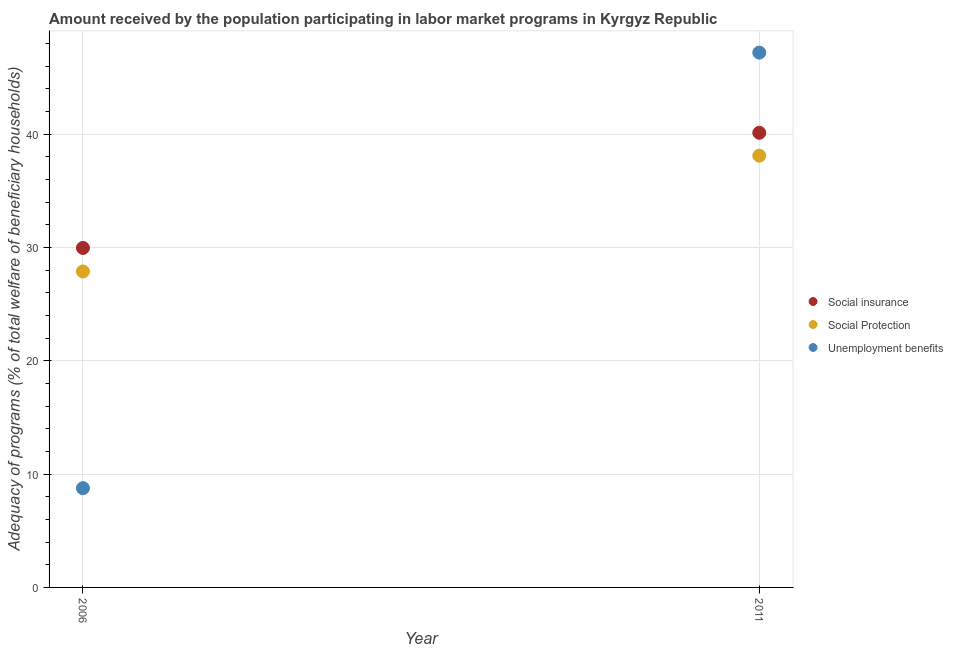How many different coloured dotlines are there?
Your response must be concise. 3. Is the number of dotlines equal to the number of legend labels?
Provide a succinct answer. Yes. What is the amount received by the population participating in social insurance programs in 2006?
Offer a very short reply. 29.96. Across all years, what is the maximum amount received by the population participating in unemployment benefits programs?
Ensure brevity in your answer.  47.19. Across all years, what is the minimum amount received by the population participating in social insurance programs?
Your answer should be very brief. 29.96. In which year was the amount received by the population participating in social protection programs minimum?
Make the answer very short. 2006. What is the total amount received by the population participating in social insurance programs in the graph?
Provide a short and direct response. 70.07. What is the difference between the amount received by the population participating in social insurance programs in 2006 and that in 2011?
Your answer should be compact. -10.16. What is the difference between the amount received by the population participating in unemployment benefits programs in 2011 and the amount received by the population participating in social protection programs in 2006?
Provide a short and direct response. 19.31. What is the average amount received by the population participating in social protection programs per year?
Ensure brevity in your answer.  32.99. In the year 2006, what is the difference between the amount received by the population participating in unemployment benefits programs and amount received by the population participating in social protection programs?
Your response must be concise. -19.12. What is the ratio of the amount received by the population participating in social insurance programs in 2006 to that in 2011?
Your answer should be very brief. 0.75. Is the amount received by the population participating in unemployment benefits programs in 2006 less than that in 2011?
Provide a short and direct response. Yes. In how many years, is the amount received by the population participating in social insurance programs greater than the average amount received by the population participating in social insurance programs taken over all years?
Your answer should be very brief. 1. Does the amount received by the population participating in social protection programs monotonically increase over the years?
Provide a short and direct response. Yes. Is the amount received by the population participating in social insurance programs strictly less than the amount received by the population participating in social protection programs over the years?
Provide a succinct answer. No. How many dotlines are there?
Keep it short and to the point. 3. How many years are there in the graph?
Provide a short and direct response. 2. What is the difference between two consecutive major ticks on the Y-axis?
Offer a very short reply. 10. Are the values on the major ticks of Y-axis written in scientific E-notation?
Provide a succinct answer. No. Does the graph contain any zero values?
Provide a succinct answer. No. Does the graph contain grids?
Provide a short and direct response. Yes. What is the title of the graph?
Your response must be concise. Amount received by the population participating in labor market programs in Kyrgyz Republic. Does "Agriculture" appear as one of the legend labels in the graph?
Your response must be concise. No. What is the label or title of the Y-axis?
Offer a very short reply. Adequacy of programs (% of total welfare of beneficiary households). What is the Adequacy of programs (% of total welfare of beneficiary households) of Social insurance in 2006?
Your answer should be compact. 29.96. What is the Adequacy of programs (% of total welfare of beneficiary households) in Social Protection in 2006?
Your answer should be very brief. 27.88. What is the Adequacy of programs (% of total welfare of beneficiary households) in Unemployment benefits in 2006?
Give a very brief answer. 8.76. What is the Adequacy of programs (% of total welfare of beneficiary households) in Social insurance in 2011?
Your answer should be very brief. 40.12. What is the Adequacy of programs (% of total welfare of beneficiary households) in Social Protection in 2011?
Provide a succinct answer. 38.1. What is the Adequacy of programs (% of total welfare of beneficiary households) in Unemployment benefits in 2011?
Your answer should be compact. 47.19. Across all years, what is the maximum Adequacy of programs (% of total welfare of beneficiary households) of Social insurance?
Keep it short and to the point. 40.12. Across all years, what is the maximum Adequacy of programs (% of total welfare of beneficiary households) of Social Protection?
Keep it short and to the point. 38.1. Across all years, what is the maximum Adequacy of programs (% of total welfare of beneficiary households) in Unemployment benefits?
Make the answer very short. 47.19. Across all years, what is the minimum Adequacy of programs (% of total welfare of beneficiary households) of Social insurance?
Your answer should be very brief. 29.96. Across all years, what is the minimum Adequacy of programs (% of total welfare of beneficiary households) in Social Protection?
Make the answer very short. 27.88. Across all years, what is the minimum Adequacy of programs (% of total welfare of beneficiary households) of Unemployment benefits?
Offer a very short reply. 8.76. What is the total Adequacy of programs (% of total welfare of beneficiary households) of Social insurance in the graph?
Your answer should be very brief. 70.07. What is the total Adequacy of programs (% of total welfare of beneficiary households) of Social Protection in the graph?
Provide a succinct answer. 65.98. What is the total Adequacy of programs (% of total welfare of beneficiary households) of Unemployment benefits in the graph?
Offer a terse response. 55.95. What is the difference between the Adequacy of programs (% of total welfare of beneficiary households) of Social insurance in 2006 and that in 2011?
Give a very brief answer. -10.16. What is the difference between the Adequacy of programs (% of total welfare of beneficiary households) of Social Protection in 2006 and that in 2011?
Your response must be concise. -10.22. What is the difference between the Adequacy of programs (% of total welfare of beneficiary households) of Unemployment benefits in 2006 and that in 2011?
Offer a terse response. -38.43. What is the difference between the Adequacy of programs (% of total welfare of beneficiary households) of Social insurance in 2006 and the Adequacy of programs (% of total welfare of beneficiary households) of Social Protection in 2011?
Offer a terse response. -8.14. What is the difference between the Adequacy of programs (% of total welfare of beneficiary households) in Social insurance in 2006 and the Adequacy of programs (% of total welfare of beneficiary households) in Unemployment benefits in 2011?
Keep it short and to the point. -17.24. What is the difference between the Adequacy of programs (% of total welfare of beneficiary households) in Social Protection in 2006 and the Adequacy of programs (% of total welfare of beneficiary households) in Unemployment benefits in 2011?
Your response must be concise. -19.31. What is the average Adequacy of programs (% of total welfare of beneficiary households) of Social insurance per year?
Make the answer very short. 35.04. What is the average Adequacy of programs (% of total welfare of beneficiary households) of Social Protection per year?
Your answer should be very brief. 32.99. What is the average Adequacy of programs (% of total welfare of beneficiary households) of Unemployment benefits per year?
Make the answer very short. 27.98. In the year 2006, what is the difference between the Adequacy of programs (% of total welfare of beneficiary households) in Social insurance and Adequacy of programs (% of total welfare of beneficiary households) in Social Protection?
Provide a short and direct response. 2.08. In the year 2006, what is the difference between the Adequacy of programs (% of total welfare of beneficiary households) of Social insurance and Adequacy of programs (% of total welfare of beneficiary households) of Unemployment benefits?
Provide a short and direct response. 21.2. In the year 2006, what is the difference between the Adequacy of programs (% of total welfare of beneficiary households) in Social Protection and Adequacy of programs (% of total welfare of beneficiary households) in Unemployment benefits?
Ensure brevity in your answer.  19.12. In the year 2011, what is the difference between the Adequacy of programs (% of total welfare of beneficiary households) in Social insurance and Adequacy of programs (% of total welfare of beneficiary households) in Social Protection?
Ensure brevity in your answer.  2.02. In the year 2011, what is the difference between the Adequacy of programs (% of total welfare of beneficiary households) of Social insurance and Adequacy of programs (% of total welfare of beneficiary households) of Unemployment benefits?
Offer a very short reply. -7.08. In the year 2011, what is the difference between the Adequacy of programs (% of total welfare of beneficiary households) of Social Protection and Adequacy of programs (% of total welfare of beneficiary households) of Unemployment benefits?
Keep it short and to the point. -9.09. What is the ratio of the Adequacy of programs (% of total welfare of beneficiary households) of Social insurance in 2006 to that in 2011?
Your answer should be compact. 0.75. What is the ratio of the Adequacy of programs (% of total welfare of beneficiary households) of Social Protection in 2006 to that in 2011?
Provide a succinct answer. 0.73. What is the ratio of the Adequacy of programs (% of total welfare of beneficiary households) in Unemployment benefits in 2006 to that in 2011?
Your response must be concise. 0.19. What is the difference between the highest and the second highest Adequacy of programs (% of total welfare of beneficiary households) of Social insurance?
Give a very brief answer. 10.16. What is the difference between the highest and the second highest Adequacy of programs (% of total welfare of beneficiary households) of Social Protection?
Offer a terse response. 10.22. What is the difference between the highest and the second highest Adequacy of programs (% of total welfare of beneficiary households) of Unemployment benefits?
Give a very brief answer. 38.43. What is the difference between the highest and the lowest Adequacy of programs (% of total welfare of beneficiary households) in Social insurance?
Make the answer very short. 10.16. What is the difference between the highest and the lowest Adequacy of programs (% of total welfare of beneficiary households) of Social Protection?
Keep it short and to the point. 10.22. What is the difference between the highest and the lowest Adequacy of programs (% of total welfare of beneficiary households) in Unemployment benefits?
Make the answer very short. 38.43. 